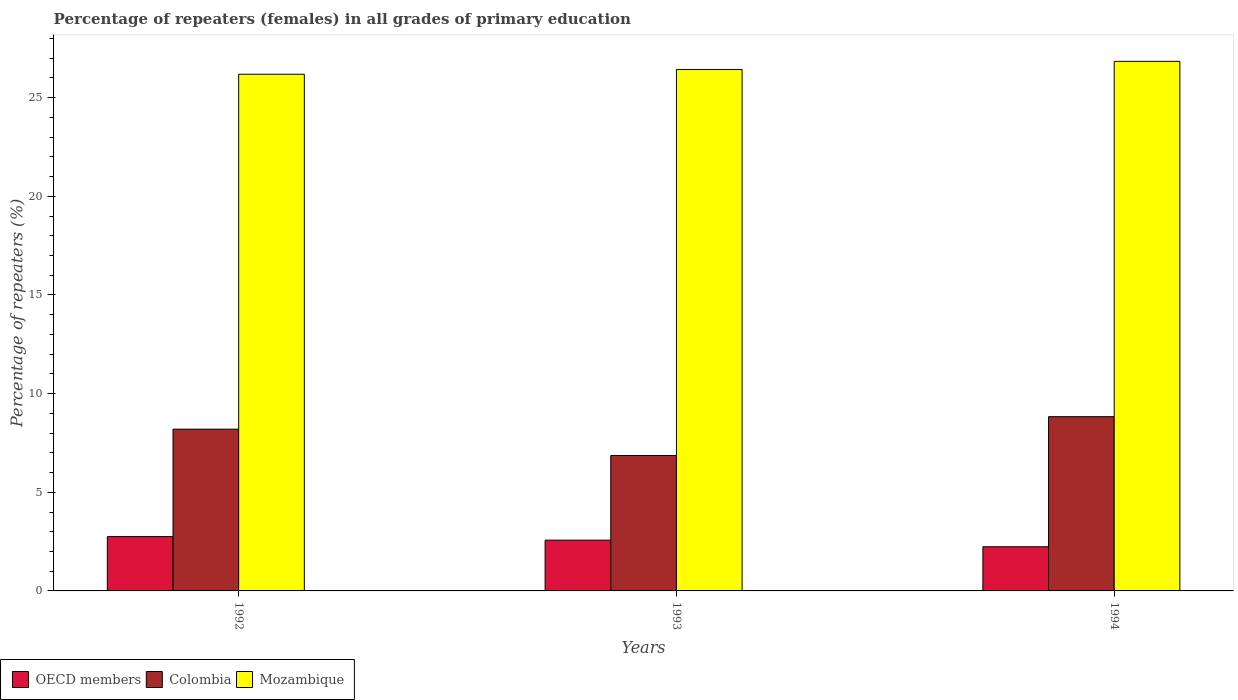How many different coloured bars are there?
Give a very brief answer. 3. How many groups of bars are there?
Give a very brief answer. 3. Are the number of bars per tick equal to the number of legend labels?
Provide a succinct answer. Yes. Are the number of bars on each tick of the X-axis equal?
Provide a short and direct response. Yes. How many bars are there on the 1st tick from the left?
Make the answer very short. 3. How many bars are there on the 2nd tick from the right?
Your response must be concise. 3. What is the label of the 3rd group of bars from the left?
Your answer should be compact. 1994. In how many cases, is the number of bars for a given year not equal to the number of legend labels?
Provide a short and direct response. 0. What is the percentage of repeaters (females) in Mozambique in 1993?
Keep it short and to the point. 26.43. Across all years, what is the maximum percentage of repeaters (females) in Mozambique?
Offer a very short reply. 26.84. Across all years, what is the minimum percentage of repeaters (females) in OECD members?
Provide a succinct answer. 2.24. What is the total percentage of repeaters (females) in Mozambique in the graph?
Offer a very short reply. 79.46. What is the difference between the percentage of repeaters (females) in Mozambique in 1992 and that in 1994?
Offer a very short reply. -0.65. What is the difference between the percentage of repeaters (females) in Colombia in 1992 and the percentage of repeaters (females) in Mozambique in 1993?
Your answer should be very brief. -18.23. What is the average percentage of repeaters (females) in OECD members per year?
Keep it short and to the point. 2.52. In the year 1993, what is the difference between the percentage of repeaters (females) in OECD members and percentage of repeaters (females) in Mozambique?
Your answer should be very brief. -23.86. In how many years, is the percentage of repeaters (females) in Colombia greater than 2 %?
Your response must be concise. 3. What is the ratio of the percentage of repeaters (females) in Mozambique in 1992 to that in 1994?
Your answer should be very brief. 0.98. Is the percentage of repeaters (females) in Colombia in 1992 less than that in 1994?
Ensure brevity in your answer.  Yes. What is the difference between the highest and the second highest percentage of repeaters (females) in Mozambique?
Your answer should be very brief. 0.41. What is the difference between the highest and the lowest percentage of repeaters (females) in Colombia?
Make the answer very short. 1.97. Is it the case that in every year, the sum of the percentage of repeaters (females) in Mozambique and percentage of repeaters (females) in OECD members is greater than the percentage of repeaters (females) in Colombia?
Keep it short and to the point. Yes. How many bars are there?
Your answer should be compact. 9. How many years are there in the graph?
Offer a terse response. 3. What is the difference between two consecutive major ticks on the Y-axis?
Your answer should be very brief. 5. Does the graph contain grids?
Your response must be concise. No. Where does the legend appear in the graph?
Provide a succinct answer. Bottom left. How many legend labels are there?
Ensure brevity in your answer.  3. How are the legend labels stacked?
Your response must be concise. Horizontal. What is the title of the graph?
Provide a succinct answer. Percentage of repeaters (females) in all grades of primary education. Does "Morocco" appear as one of the legend labels in the graph?
Provide a succinct answer. No. What is the label or title of the X-axis?
Your response must be concise. Years. What is the label or title of the Y-axis?
Your answer should be compact. Percentage of repeaters (%). What is the Percentage of repeaters (%) in OECD members in 1992?
Offer a very short reply. 2.75. What is the Percentage of repeaters (%) in Colombia in 1992?
Offer a very short reply. 8.2. What is the Percentage of repeaters (%) of Mozambique in 1992?
Your response must be concise. 26.19. What is the Percentage of repeaters (%) of OECD members in 1993?
Offer a terse response. 2.57. What is the Percentage of repeaters (%) in Colombia in 1993?
Keep it short and to the point. 6.86. What is the Percentage of repeaters (%) of Mozambique in 1993?
Offer a very short reply. 26.43. What is the Percentage of repeaters (%) of OECD members in 1994?
Provide a succinct answer. 2.24. What is the Percentage of repeaters (%) of Colombia in 1994?
Provide a short and direct response. 8.83. What is the Percentage of repeaters (%) in Mozambique in 1994?
Provide a short and direct response. 26.84. Across all years, what is the maximum Percentage of repeaters (%) in OECD members?
Offer a very short reply. 2.75. Across all years, what is the maximum Percentage of repeaters (%) in Colombia?
Give a very brief answer. 8.83. Across all years, what is the maximum Percentage of repeaters (%) in Mozambique?
Ensure brevity in your answer.  26.84. Across all years, what is the minimum Percentage of repeaters (%) of OECD members?
Make the answer very short. 2.24. Across all years, what is the minimum Percentage of repeaters (%) in Colombia?
Provide a short and direct response. 6.86. Across all years, what is the minimum Percentage of repeaters (%) of Mozambique?
Offer a terse response. 26.19. What is the total Percentage of repeaters (%) of OECD members in the graph?
Your response must be concise. 7.57. What is the total Percentage of repeaters (%) in Colombia in the graph?
Your answer should be compact. 23.89. What is the total Percentage of repeaters (%) of Mozambique in the graph?
Provide a short and direct response. 79.46. What is the difference between the Percentage of repeaters (%) of OECD members in 1992 and that in 1993?
Keep it short and to the point. 0.18. What is the difference between the Percentage of repeaters (%) in Colombia in 1992 and that in 1993?
Provide a succinct answer. 1.34. What is the difference between the Percentage of repeaters (%) of Mozambique in 1992 and that in 1993?
Give a very brief answer. -0.24. What is the difference between the Percentage of repeaters (%) of OECD members in 1992 and that in 1994?
Give a very brief answer. 0.52. What is the difference between the Percentage of repeaters (%) in Colombia in 1992 and that in 1994?
Offer a terse response. -0.63. What is the difference between the Percentage of repeaters (%) in Mozambique in 1992 and that in 1994?
Your response must be concise. -0.65. What is the difference between the Percentage of repeaters (%) in OECD members in 1993 and that in 1994?
Give a very brief answer. 0.34. What is the difference between the Percentage of repeaters (%) in Colombia in 1993 and that in 1994?
Make the answer very short. -1.97. What is the difference between the Percentage of repeaters (%) of Mozambique in 1993 and that in 1994?
Ensure brevity in your answer.  -0.41. What is the difference between the Percentage of repeaters (%) in OECD members in 1992 and the Percentage of repeaters (%) in Colombia in 1993?
Ensure brevity in your answer.  -4.11. What is the difference between the Percentage of repeaters (%) of OECD members in 1992 and the Percentage of repeaters (%) of Mozambique in 1993?
Ensure brevity in your answer.  -23.67. What is the difference between the Percentage of repeaters (%) in Colombia in 1992 and the Percentage of repeaters (%) in Mozambique in 1993?
Your response must be concise. -18.23. What is the difference between the Percentage of repeaters (%) in OECD members in 1992 and the Percentage of repeaters (%) in Colombia in 1994?
Ensure brevity in your answer.  -6.08. What is the difference between the Percentage of repeaters (%) of OECD members in 1992 and the Percentage of repeaters (%) of Mozambique in 1994?
Your response must be concise. -24.09. What is the difference between the Percentage of repeaters (%) of Colombia in 1992 and the Percentage of repeaters (%) of Mozambique in 1994?
Give a very brief answer. -18.64. What is the difference between the Percentage of repeaters (%) in OECD members in 1993 and the Percentage of repeaters (%) in Colombia in 1994?
Offer a terse response. -6.26. What is the difference between the Percentage of repeaters (%) in OECD members in 1993 and the Percentage of repeaters (%) in Mozambique in 1994?
Make the answer very short. -24.27. What is the difference between the Percentage of repeaters (%) in Colombia in 1993 and the Percentage of repeaters (%) in Mozambique in 1994?
Offer a terse response. -19.98. What is the average Percentage of repeaters (%) of OECD members per year?
Offer a very short reply. 2.52. What is the average Percentage of repeaters (%) in Colombia per year?
Offer a terse response. 7.96. What is the average Percentage of repeaters (%) of Mozambique per year?
Your response must be concise. 26.49. In the year 1992, what is the difference between the Percentage of repeaters (%) in OECD members and Percentage of repeaters (%) in Colombia?
Ensure brevity in your answer.  -5.44. In the year 1992, what is the difference between the Percentage of repeaters (%) in OECD members and Percentage of repeaters (%) in Mozambique?
Make the answer very short. -23.43. In the year 1992, what is the difference between the Percentage of repeaters (%) in Colombia and Percentage of repeaters (%) in Mozambique?
Keep it short and to the point. -17.99. In the year 1993, what is the difference between the Percentage of repeaters (%) of OECD members and Percentage of repeaters (%) of Colombia?
Provide a short and direct response. -4.29. In the year 1993, what is the difference between the Percentage of repeaters (%) of OECD members and Percentage of repeaters (%) of Mozambique?
Offer a very short reply. -23.86. In the year 1993, what is the difference between the Percentage of repeaters (%) in Colombia and Percentage of repeaters (%) in Mozambique?
Provide a short and direct response. -19.57. In the year 1994, what is the difference between the Percentage of repeaters (%) of OECD members and Percentage of repeaters (%) of Colombia?
Make the answer very short. -6.59. In the year 1994, what is the difference between the Percentage of repeaters (%) in OECD members and Percentage of repeaters (%) in Mozambique?
Provide a succinct answer. -24.6. In the year 1994, what is the difference between the Percentage of repeaters (%) of Colombia and Percentage of repeaters (%) of Mozambique?
Offer a very short reply. -18.01. What is the ratio of the Percentage of repeaters (%) in OECD members in 1992 to that in 1993?
Your answer should be compact. 1.07. What is the ratio of the Percentage of repeaters (%) of Colombia in 1992 to that in 1993?
Give a very brief answer. 1.19. What is the ratio of the Percentage of repeaters (%) of Mozambique in 1992 to that in 1993?
Provide a short and direct response. 0.99. What is the ratio of the Percentage of repeaters (%) of OECD members in 1992 to that in 1994?
Give a very brief answer. 1.23. What is the ratio of the Percentage of repeaters (%) of Colombia in 1992 to that in 1994?
Your response must be concise. 0.93. What is the ratio of the Percentage of repeaters (%) in Mozambique in 1992 to that in 1994?
Your answer should be compact. 0.98. What is the ratio of the Percentage of repeaters (%) in OECD members in 1993 to that in 1994?
Your answer should be compact. 1.15. What is the ratio of the Percentage of repeaters (%) of Colombia in 1993 to that in 1994?
Offer a terse response. 0.78. What is the ratio of the Percentage of repeaters (%) in Mozambique in 1993 to that in 1994?
Offer a terse response. 0.98. What is the difference between the highest and the second highest Percentage of repeaters (%) of OECD members?
Offer a very short reply. 0.18. What is the difference between the highest and the second highest Percentage of repeaters (%) in Colombia?
Make the answer very short. 0.63. What is the difference between the highest and the second highest Percentage of repeaters (%) of Mozambique?
Provide a short and direct response. 0.41. What is the difference between the highest and the lowest Percentage of repeaters (%) in OECD members?
Keep it short and to the point. 0.52. What is the difference between the highest and the lowest Percentage of repeaters (%) in Colombia?
Your answer should be very brief. 1.97. What is the difference between the highest and the lowest Percentage of repeaters (%) of Mozambique?
Your answer should be very brief. 0.65. 